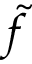Convert formula to latex. <formula><loc_0><loc_0><loc_500><loc_500>\tilde { f }</formula> 